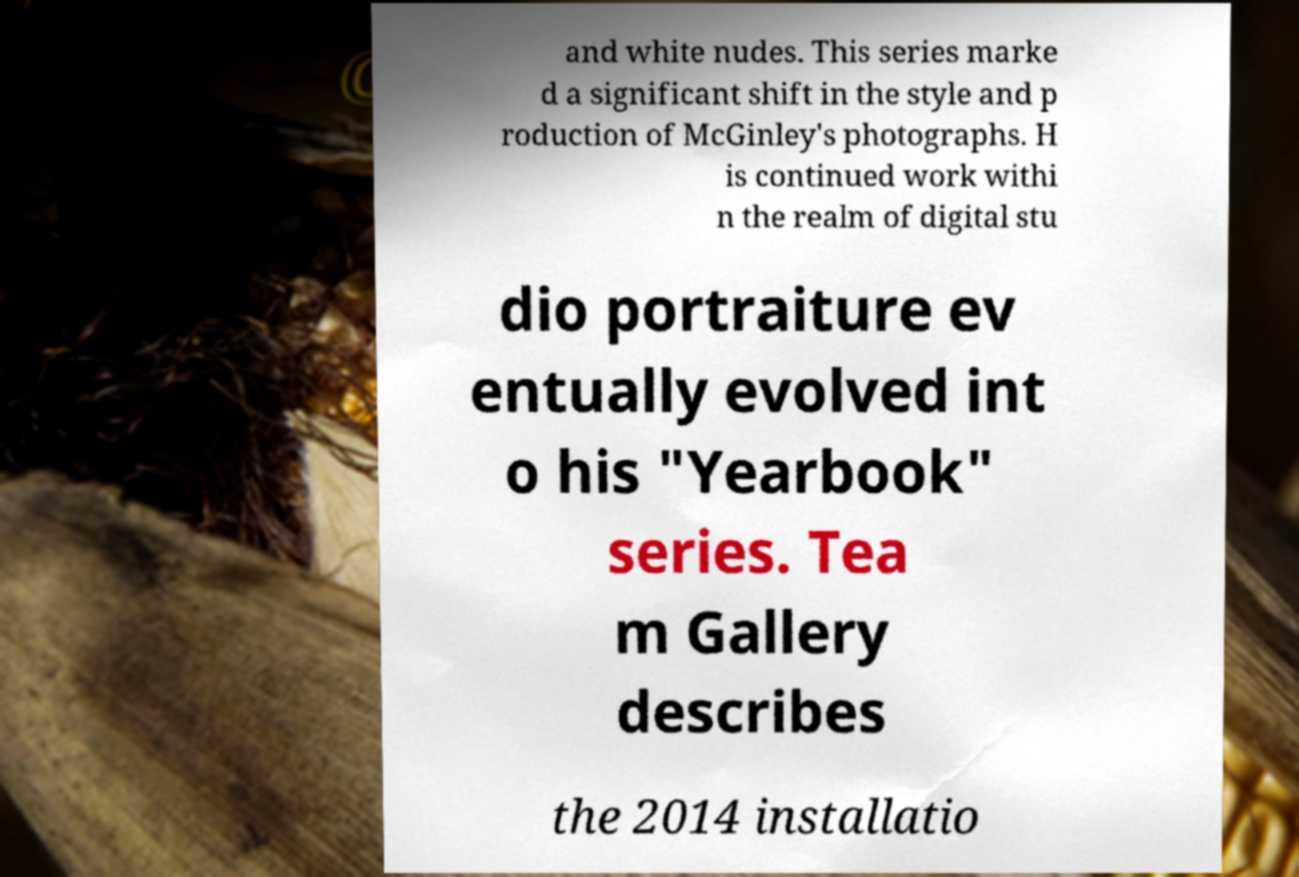Can you read and provide the text displayed in the image?This photo seems to have some interesting text. Can you extract and type it out for me? and white nudes. This series marke d a significant shift in the style and p roduction of McGinley's photographs. H is continued work withi n the realm of digital stu dio portraiture ev entually evolved int o his "Yearbook" series. Tea m Gallery describes the 2014 installatio 